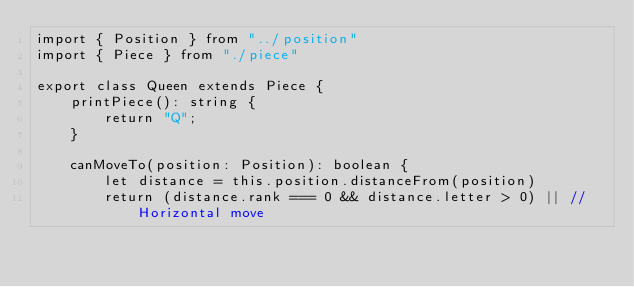Convert code to text. <code><loc_0><loc_0><loc_500><loc_500><_TypeScript_>import { Position } from "../position"
import { Piece } from "./piece"

export class Queen extends Piece {
    printPiece(): string {
        return "Q";
    }

    canMoveTo(position: Position): boolean {
        let distance = this.position.distanceFrom(position)
        return (distance.rank === 0 && distance.letter > 0) || // Horizontal move</code> 